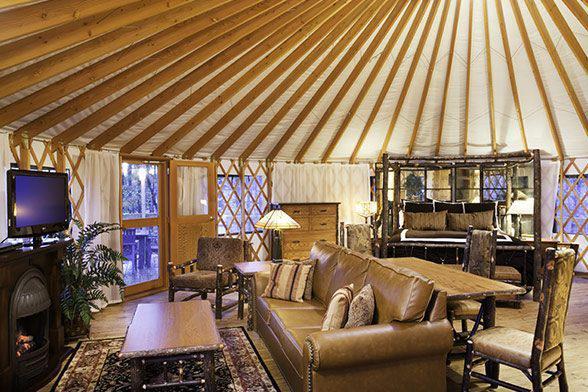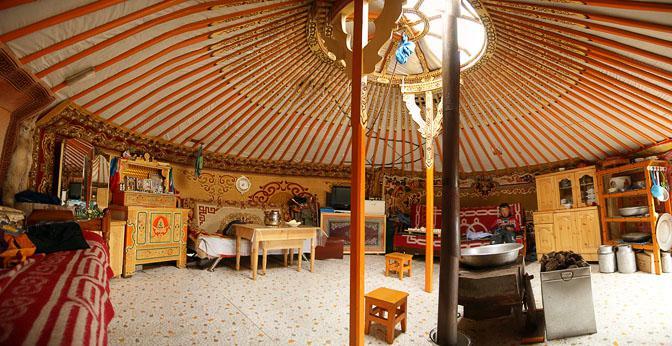The first image is the image on the left, the second image is the image on the right. Given the left and right images, does the statement "A room with a fan-like ceiling contains an over-stuffed beige couch facing a fireplace with flame-glow in it." hold true? Answer yes or no. Yes. 